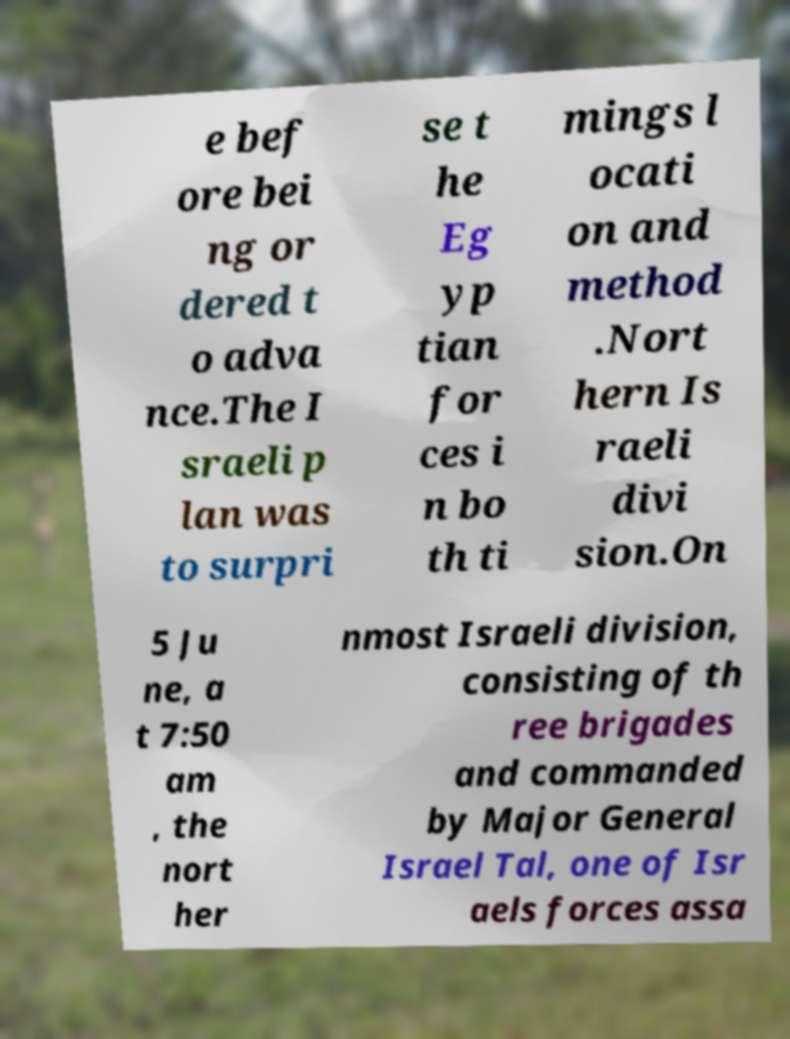Can you accurately transcribe the text from the provided image for me? e bef ore bei ng or dered t o adva nce.The I sraeli p lan was to surpri se t he Eg yp tian for ces i n bo th ti mings l ocati on and method .Nort hern Is raeli divi sion.On 5 Ju ne, a t 7:50 am , the nort her nmost Israeli division, consisting of th ree brigades and commanded by Major General Israel Tal, one of Isr aels forces assa 